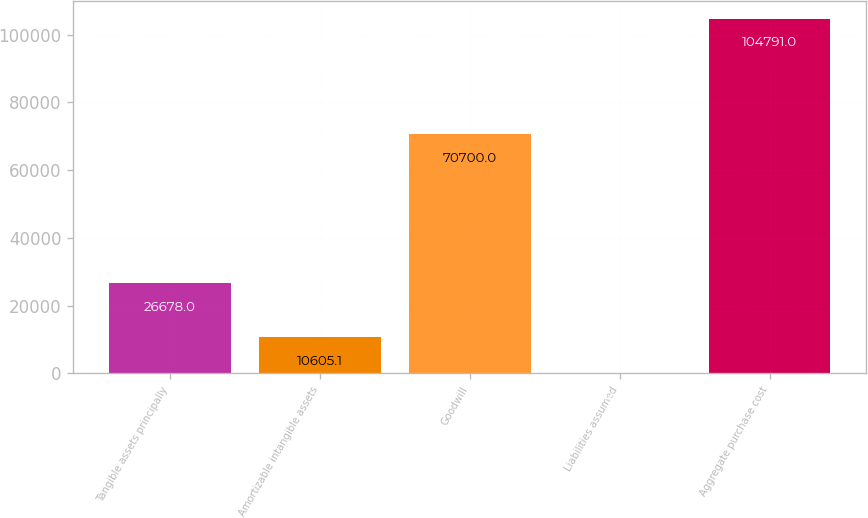Convert chart. <chart><loc_0><loc_0><loc_500><loc_500><bar_chart><fcel>Tangible assets principally<fcel>Amortizable intangible assets<fcel>Goodwill<fcel>Liabilities assumed<fcel>Aggregate purchase cost<nl><fcel>26678<fcel>10605.1<fcel>70700<fcel>140<fcel>104791<nl></chart> 